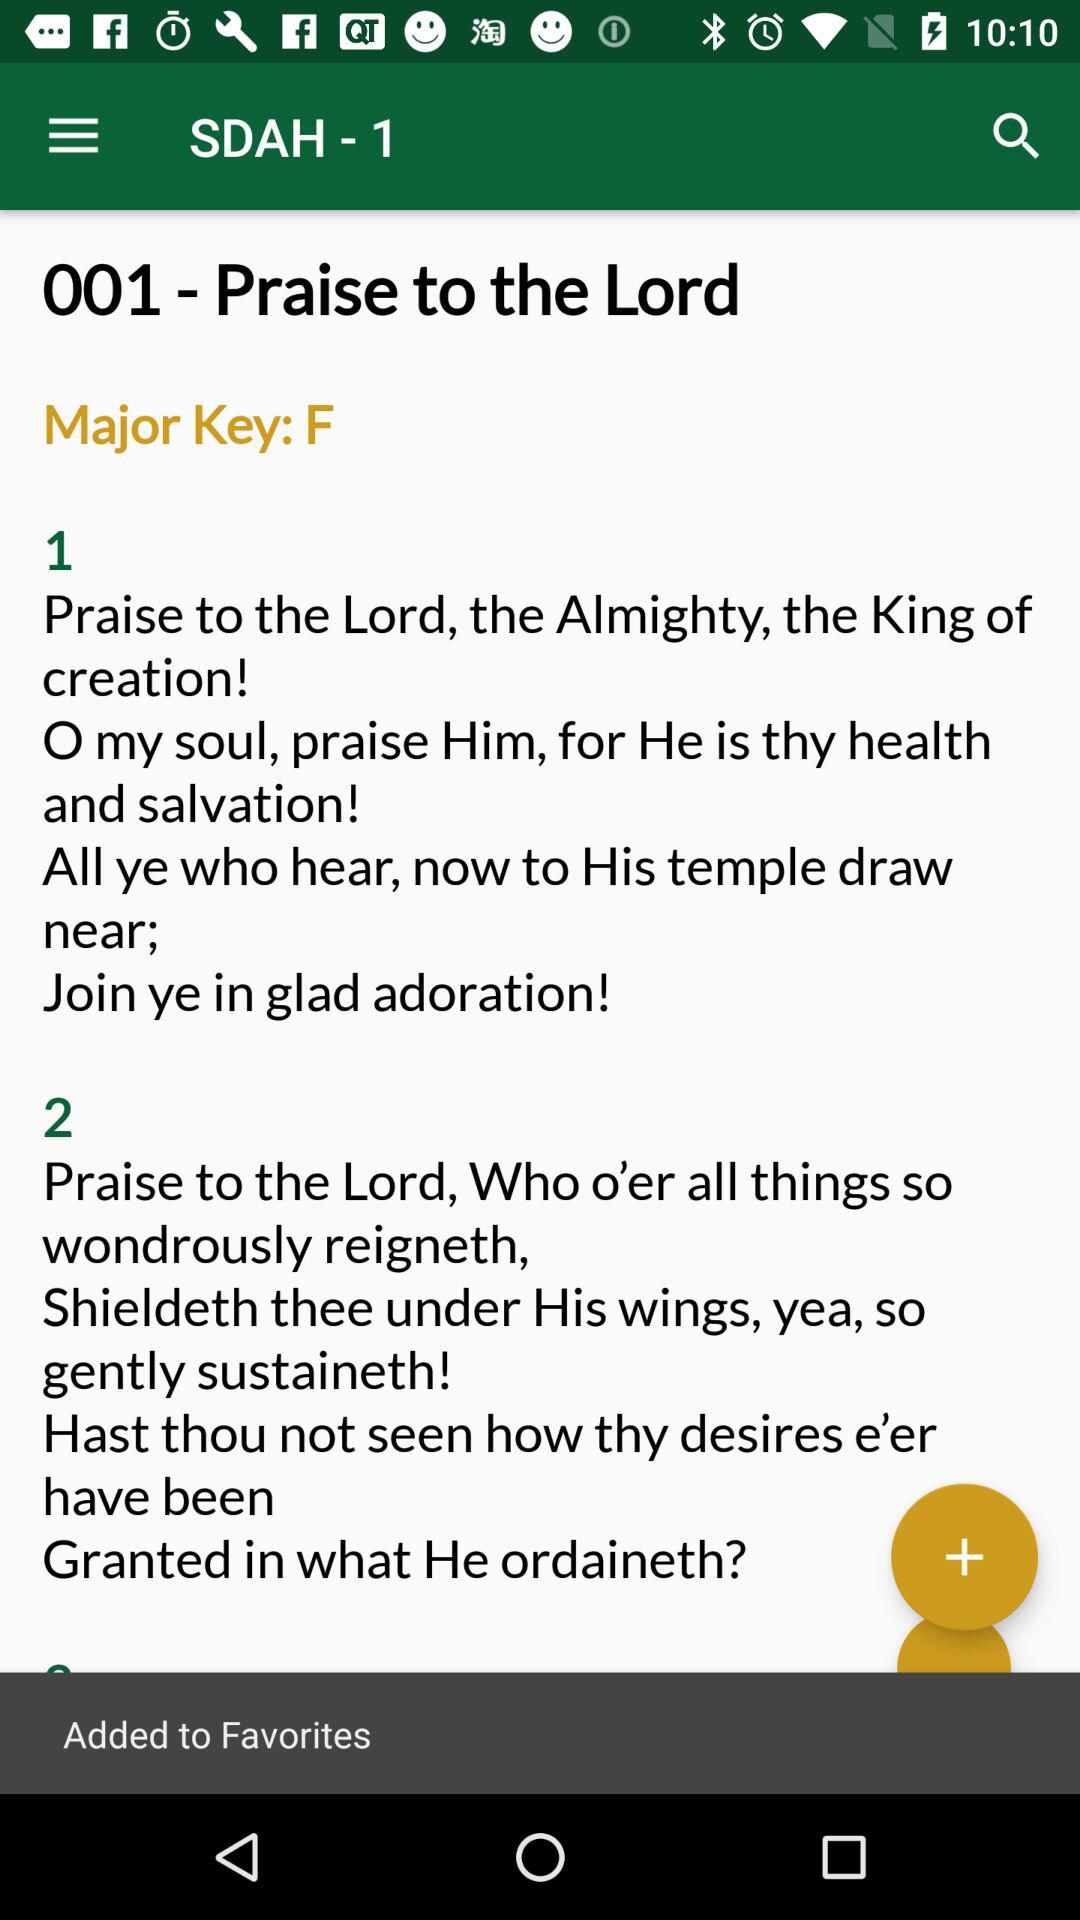How many verses are there in the song?
Answer the question using a single word or phrase. 2 